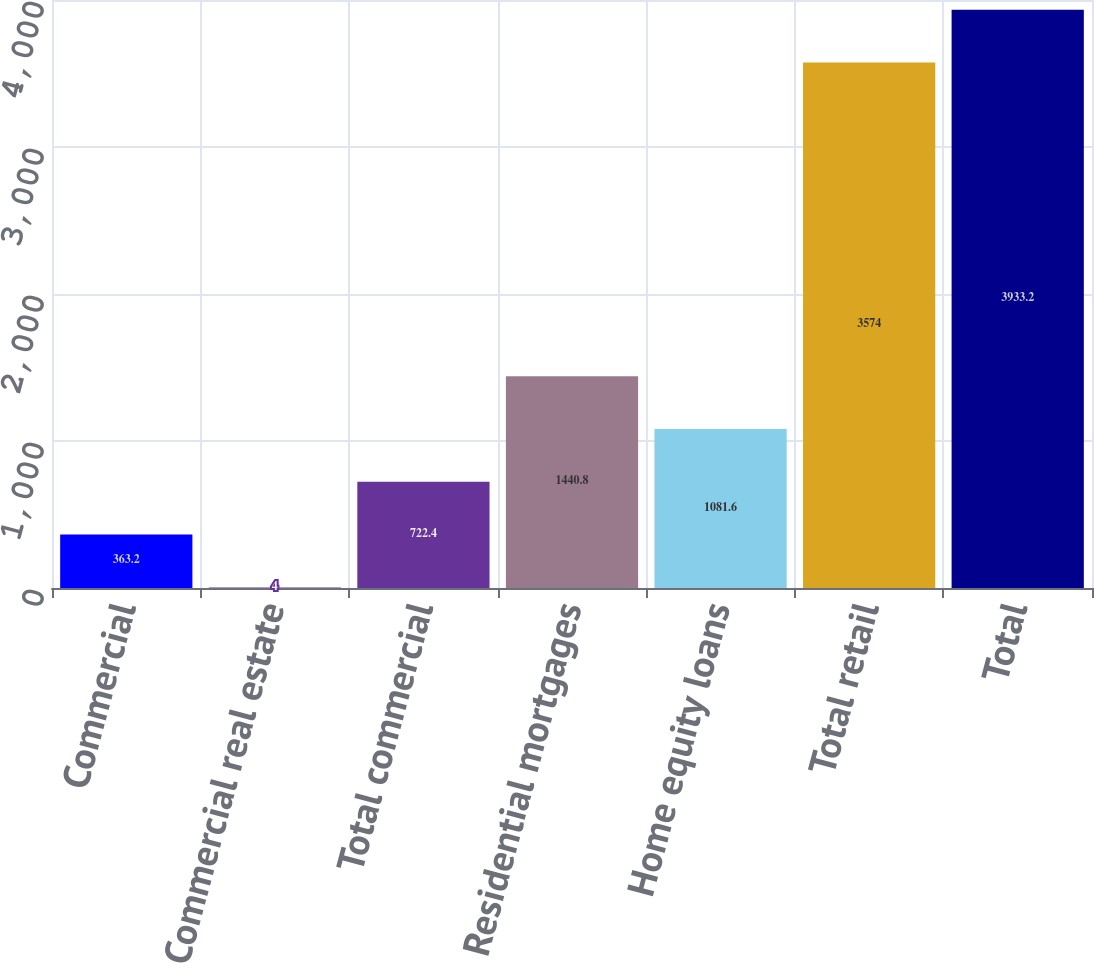Convert chart to OTSL. <chart><loc_0><loc_0><loc_500><loc_500><bar_chart><fcel>Commercial<fcel>Commercial real estate<fcel>Total commercial<fcel>Residential mortgages<fcel>Home equity loans<fcel>Total retail<fcel>Total<nl><fcel>363.2<fcel>4<fcel>722.4<fcel>1440.8<fcel>1081.6<fcel>3574<fcel>3933.2<nl></chart> 